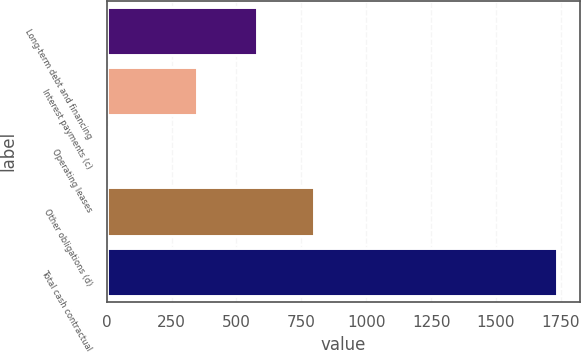Convert chart. <chart><loc_0><loc_0><loc_500><loc_500><bar_chart><fcel>Long-term debt and financing<fcel>Interest payments (c)<fcel>Operating leases<fcel>Other obligations (d)<fcel>Total cash contractual<nl><fcel>580<fcel>348<fcel>10<fcel>799<fcel>1737<nl></chart> 